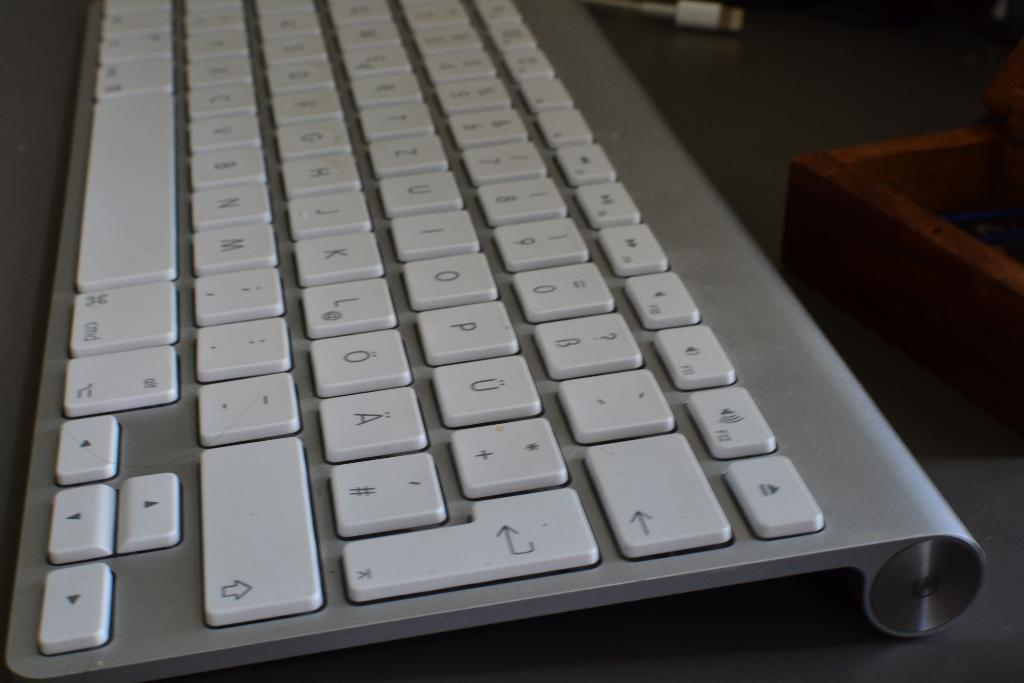Provide a one-sentence caption for the provided image. An Apple keyboard with standard cmd and eject buttons. 